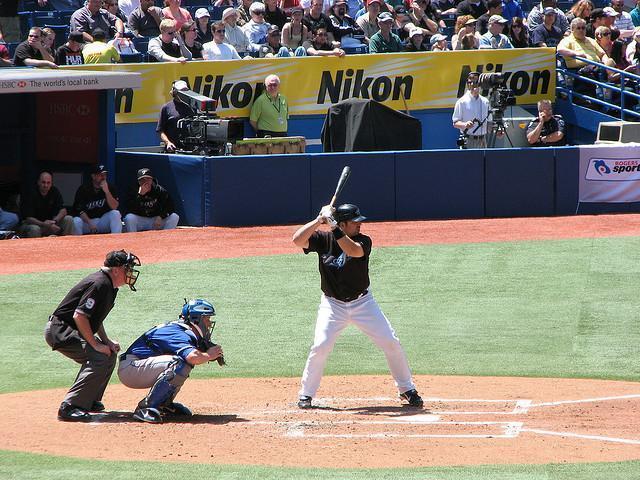How many people are there?
Give a very brief answer. 7. 